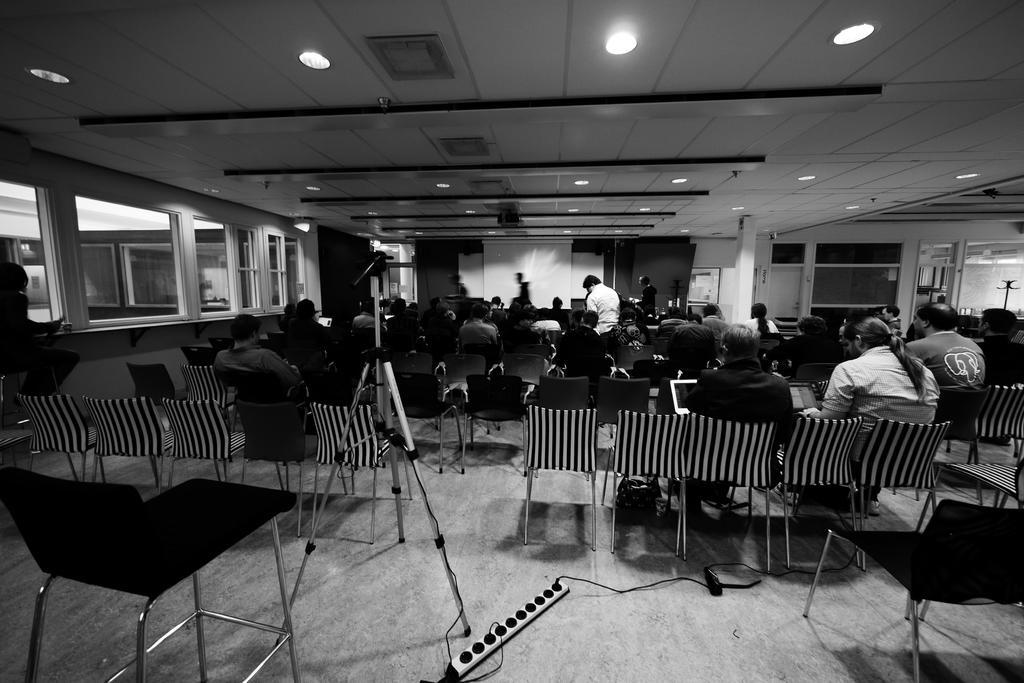Could you give a brief overview of what you see in this image? In this image I can see number of chairs and number of people on it. In the background I can see a projector's screen. 